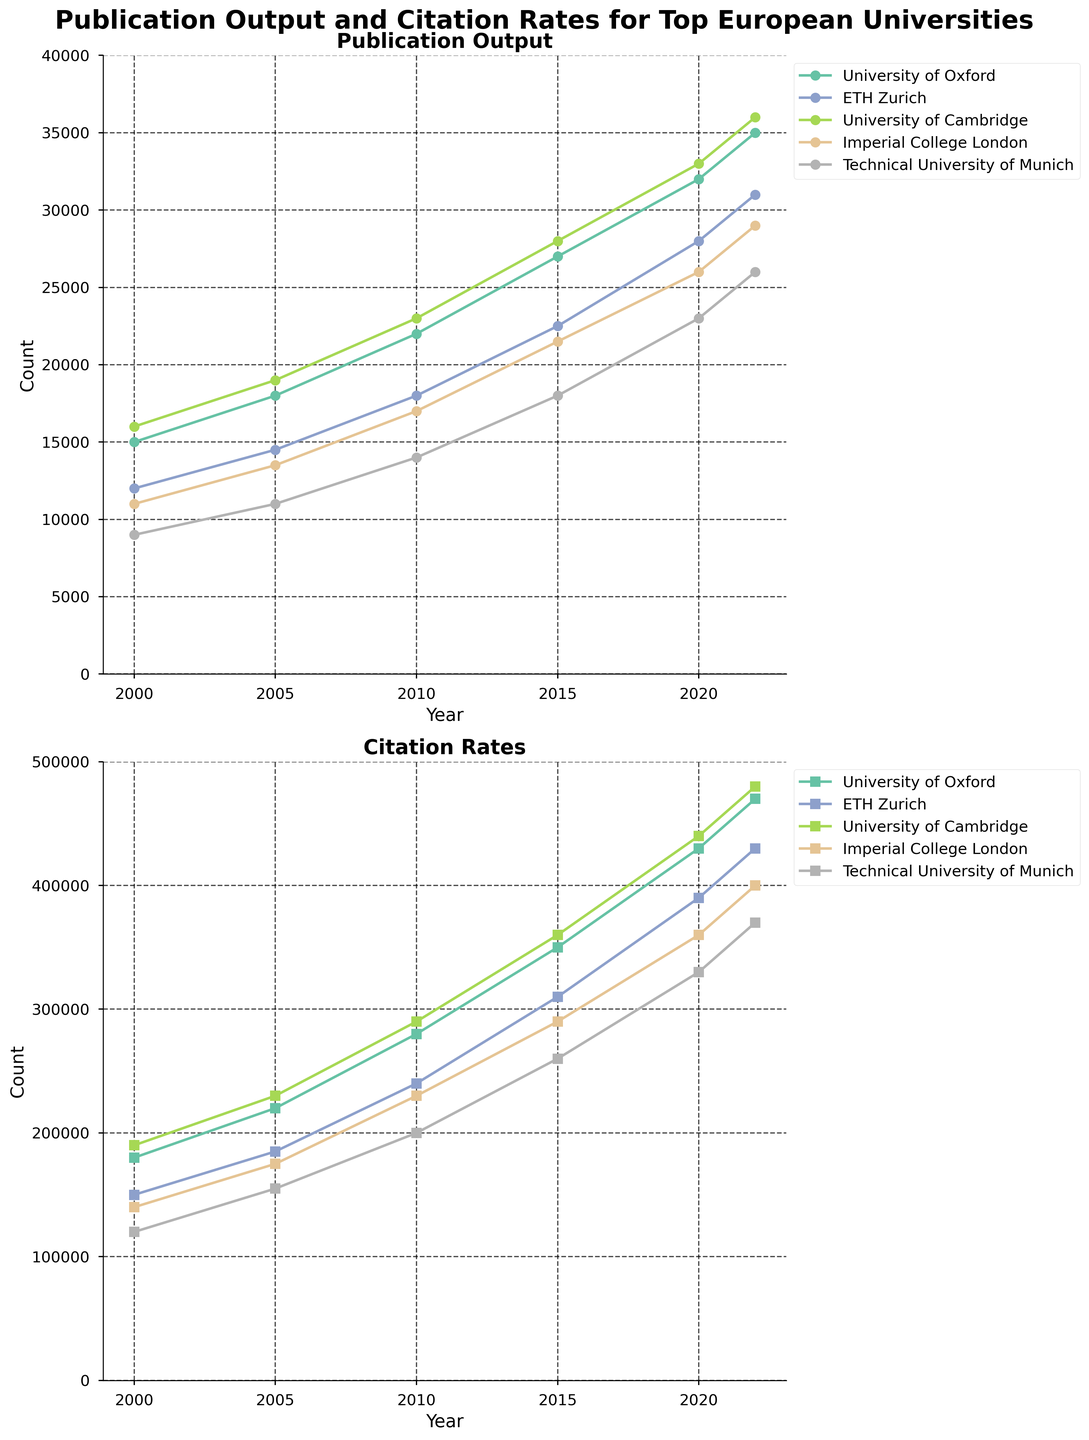What is the title of the figure? The title of the figure is usually displayed at the top and is in bold letters. By looking at the top of the figure, one can see that the title is 'Publication Output and Citation Rates for Top European Universities'.
Answer: Publication Output and Citation Rates for Top European Universities How many universities are represented in the charts? The legend on the right side of the charts lists all the universities. Counting the entries, we see that there are five universities represented.
Answer: Five What is the y-axis range for the Publication Output chart? The y-axis range can be identified by looking at the left side of the Publication Output subplot. It starts from 0 and goes up to 40000.
Answer: 0 to 40000 Which university had the highest publication output in 2022? By examining the 2022 data points on the Publication Output chart and looking for the highest point, we see that the University of Cambridge had the highest publication output in 2022.
Answer: University of Cambridge What was the citation rate of ETH Zurich in 2015? By locating ETH Zurich's line in the Citation Rates chart and finding the data point corresponding to the year 2015, we see the citation rate was 310,000.
Answer: 310,000 Comparatively, did Imperial College London have more citations in 2010 or 2020? To answer this, we need to look at Imperial College London’s citation data points for 2010 and 2020 in the Citation Rates chart. In 2010, it had 230,000 citations, and in 2020, it had 360,000 citations. Therefore, it had more citations in 2020.
Answer: 2020 What is the average publication output of the University of Oxford from 2000 to 2022? To find the average, sum the publication outputs of the University of Oxford from 2000 to 2022: \( 15000 + 18000 + 22000 + 27000 + 32000 + 35000 = 149000 \). Divide this sum by the number of data points (6): \( 149000 / 6 \approx 24833 \).
Answer: 24833 Which university had the lowest publication output in 2005? By locating the 2005 data points in the Publication Output chart and comparing them, we find that the Technical University of Munich had the lowest output with 11,000 publications.
Answer: Technical University of Munich What is the difference in citation rates between the University of Cambridge and Technical University of Munich in 2022? To find the difference, look at the 2022 citation rates for both universities in the Citation Rates chart. The University of Cambridge has 480,000 citations, and the Technical University of Munich has 370,000 citations. Subtract the latter from the former: \( 480000 - 370000 = 110000 \).
Answer: 110000 Which subplot indicates a steeper growth rate over time for the represented universities? Comparing the slopes of the lines in both subplots indicates the rate of growth. The Citation Rates subplot shows a steeper growth for the universities over time compared to the Publication Output subplot.
Answer: Citation Rates 